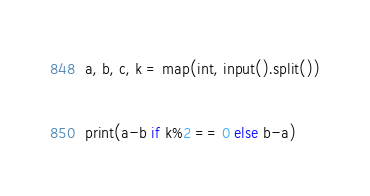Convert code to text. <code><loc_0><loc_0><loc_500><loc_500><_Python_>a, b, c, k = map(int, input().split())

print(a-b if k%2 == 0 else b-a)
</code> 